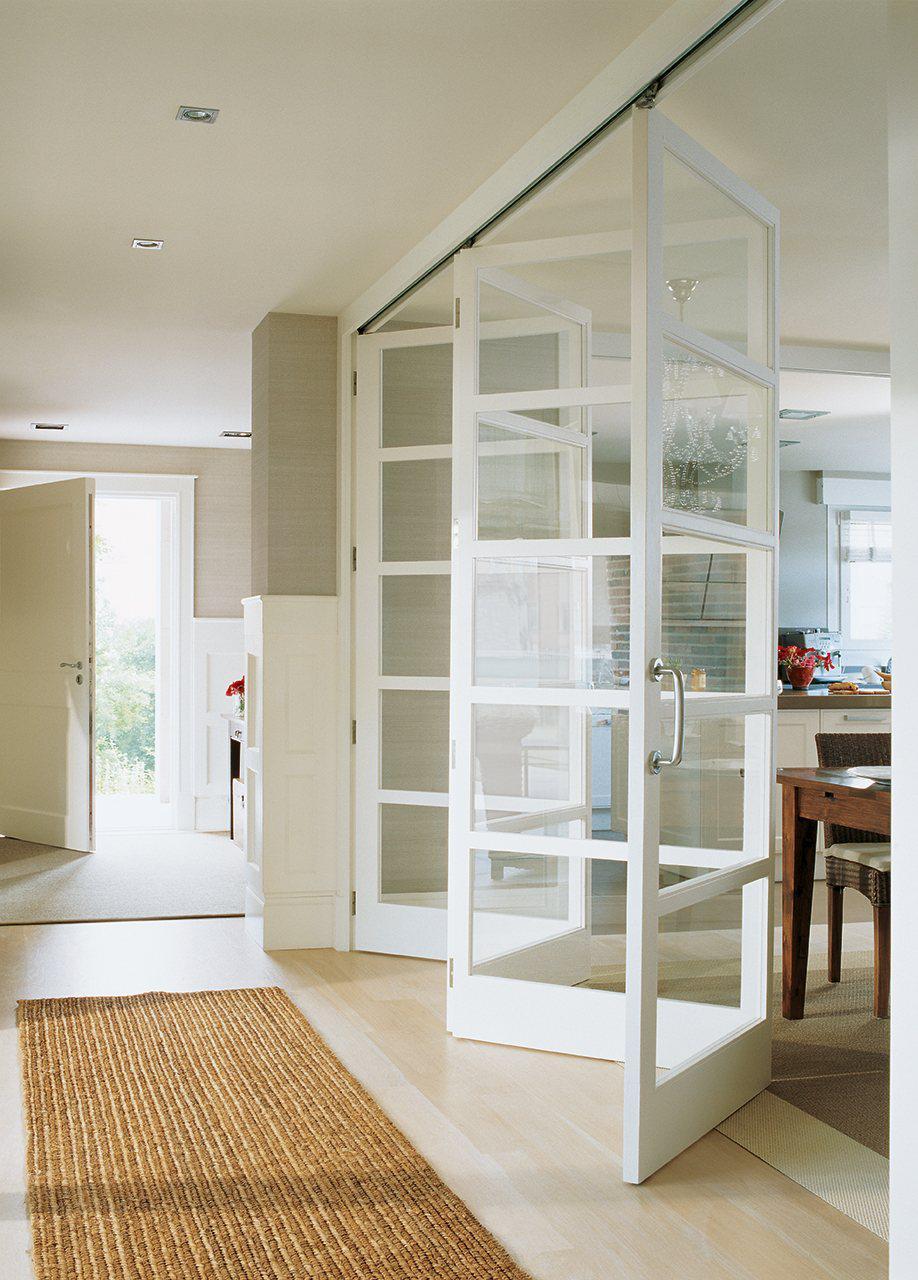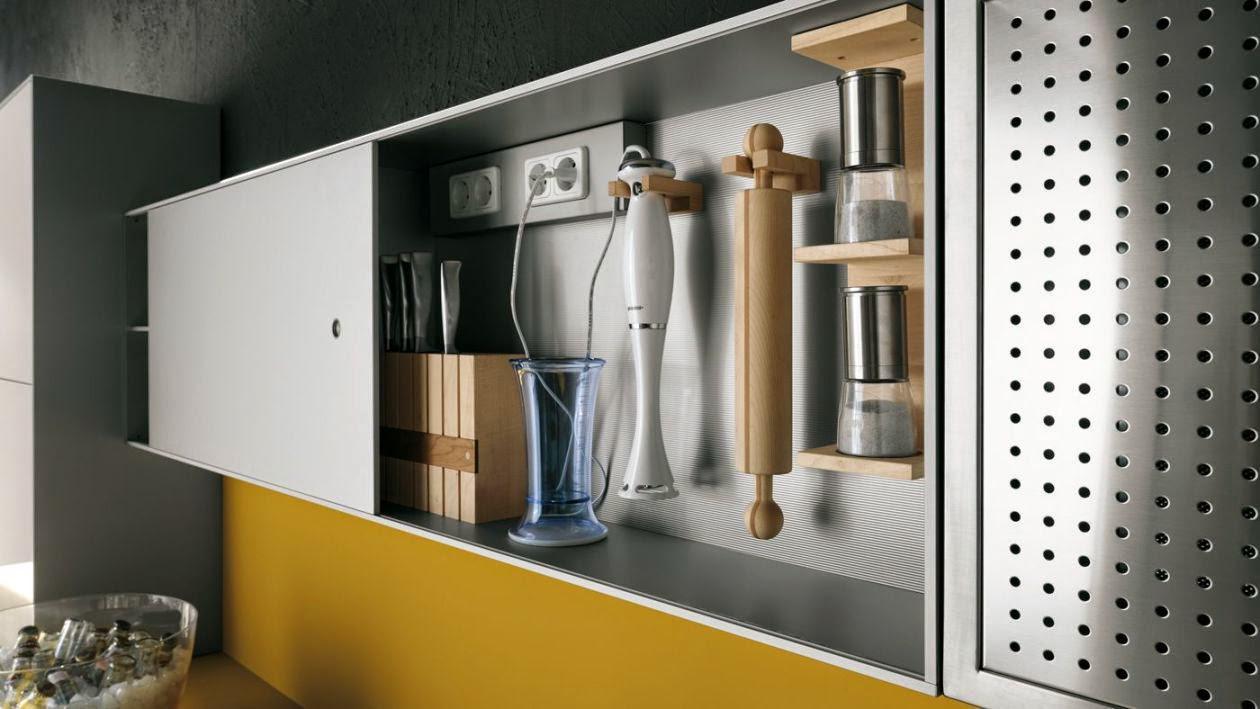The first image is the image on the left, the second image is the image on the right. Given the left and right images, does the statement "In one image, at least one door panel with white frame and glass inserts is shown in an open position." hold true? Answer yes or no. Yes. The first image is the image on the left, the second image is the image on the right. Assess this claim about the two images: "Chairs sit near a table in a home.". Correct or not? Answer yes or no. No. 